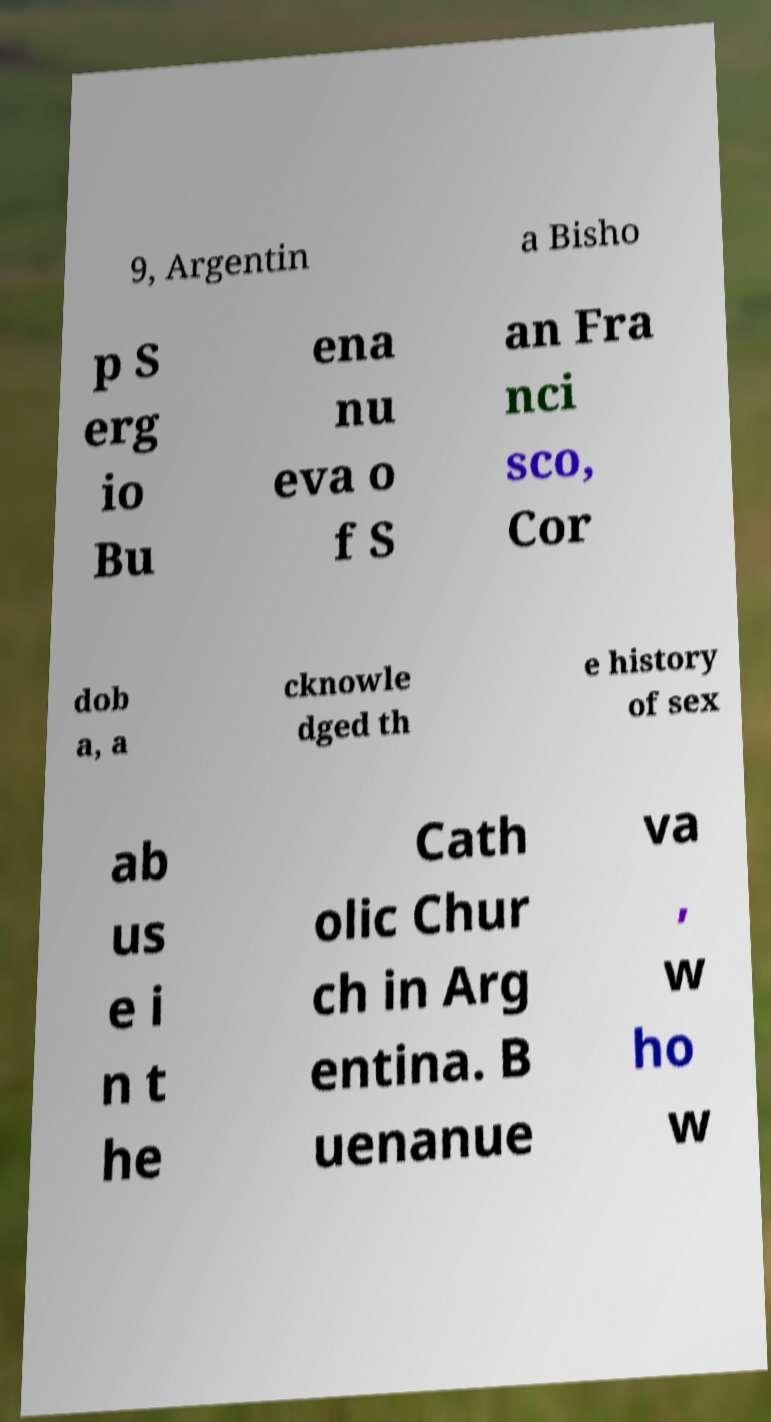What messages or text are displayed in this image? I need them in a readable, typed format. 9, Argentin a Bisho p S erg io Bu ena nu eva o f S an Fra nci sco, Cor dob a, a cknowle dged th e history of sex ab us e i n t he Cath olic Chur ch in Arg entina. B uenanue va , w ho w 